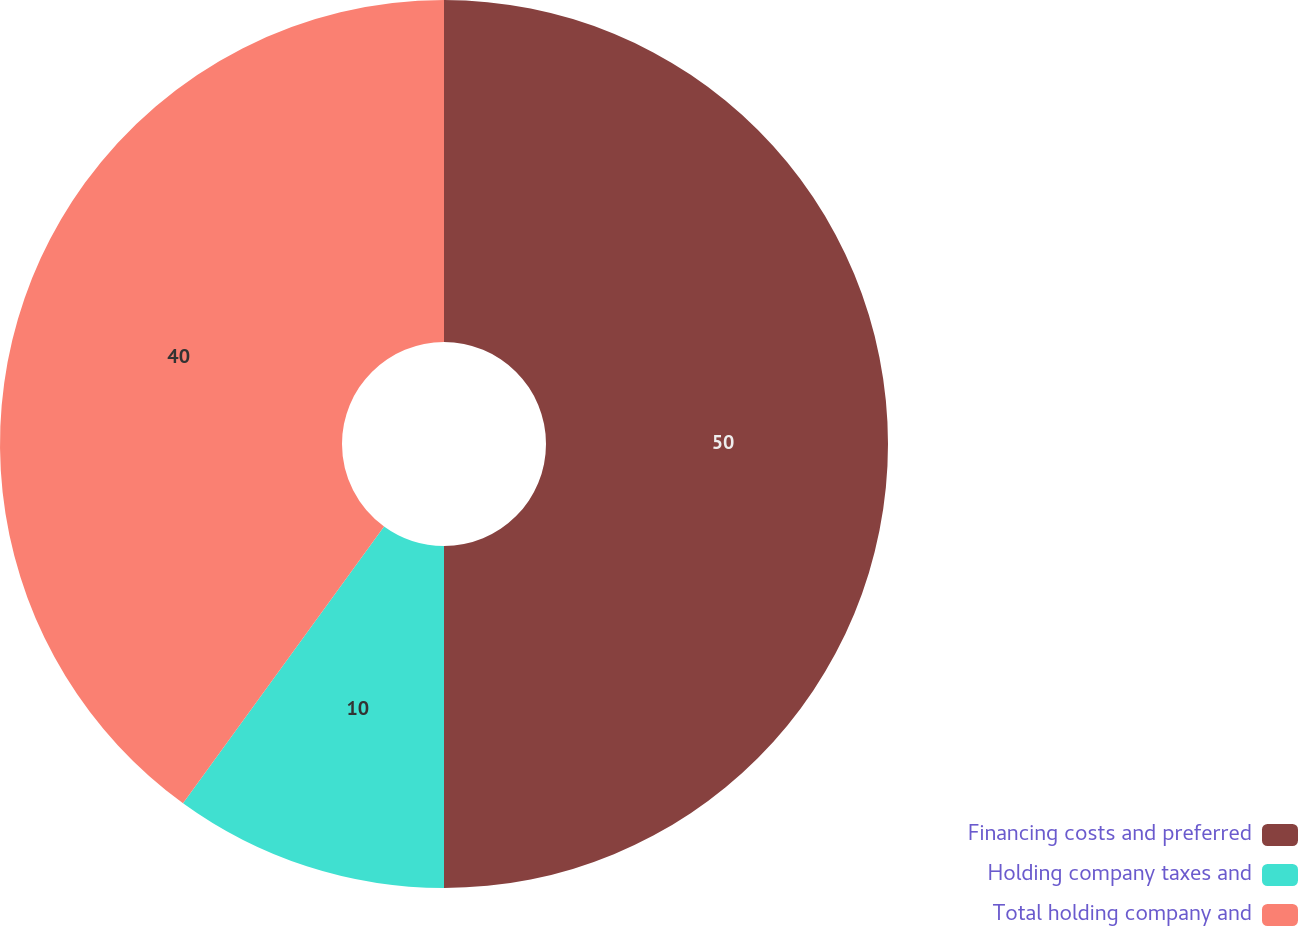<chart> <loc_0><loc_0><loc_500><loc_500><pie_chart><fcel>Financing costs and preferred<fcel>Holding company taxes and<fcel>Total holding company and<nl><fcel>50.0%<fcel>10.0%<fcel>40.0%<nl></chart> 